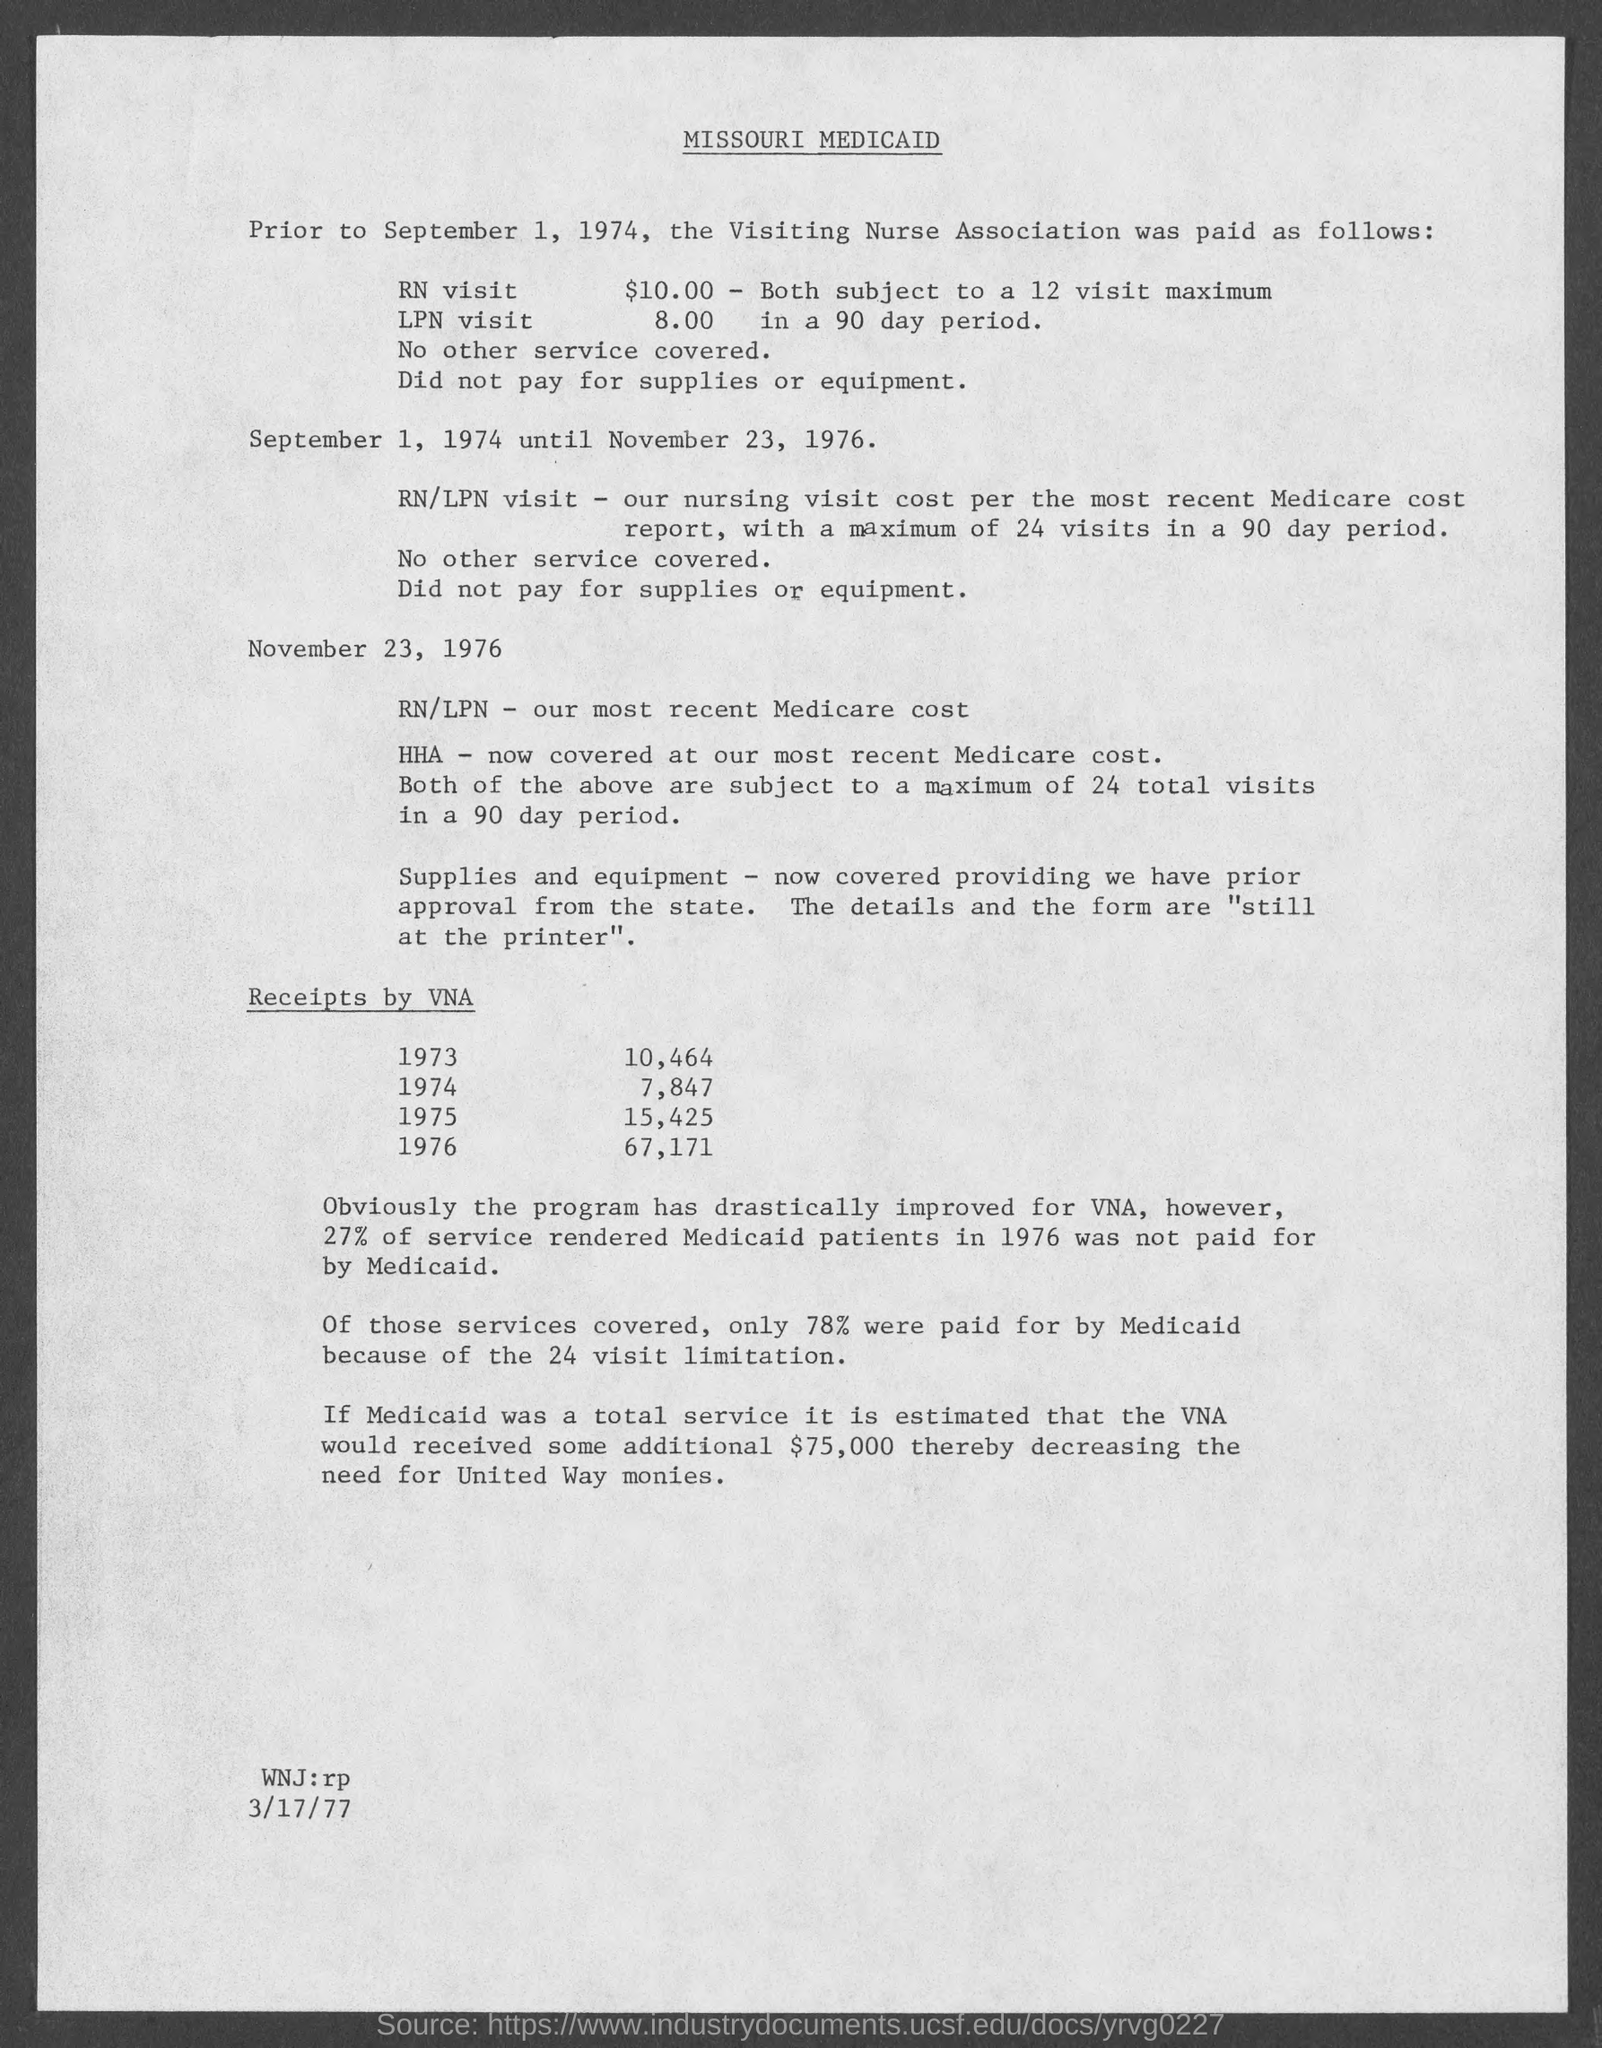Highlight a few significant elements in this photo. The document at the bottom mentions a date of March 17, 1977. The first date mentioned in the document is September 1, 1974. 